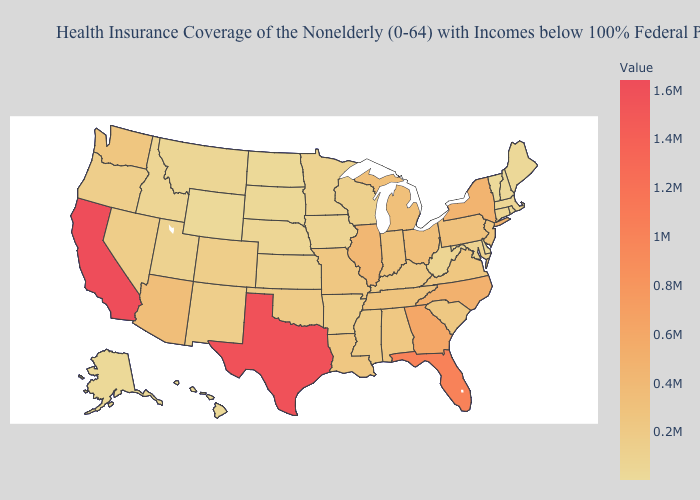Among the states that border Florida , does Georgia have the lowest value?
Keep it brief. No. Is the legend a continuous bar?
Answer briefly. Yes. Which states have the highest value in the USA?
Answer briefly. California. Does the map have missing data?
Short answer required. No. Does North Dakota have the lowest value in the MidWest?
Concise answer only. Yes. 